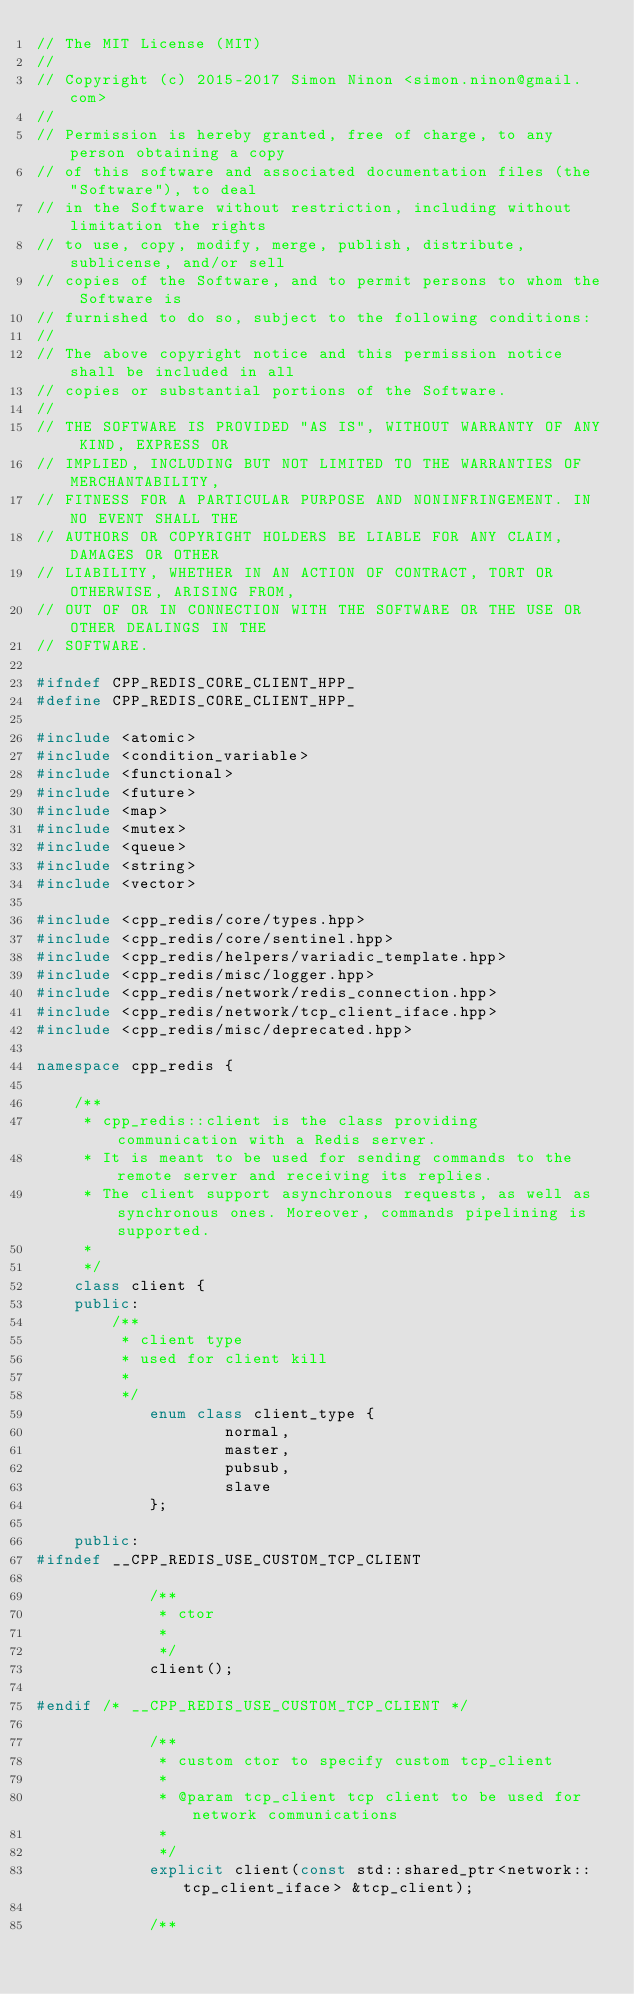Convert code to text. <code><loc_0><loc_0><loc_500><loc_500><_C++_>// The MIT License (MIT)
//
// Copyright (c) 2015-2017 Simon Ninon <simon.ninon@gmail.com>
//
// Permission is hereby granted, free of charge, to any person obtaining a copy
// of this software and associated documentation files (the "Software"), to deal
// in the Software without restriction, including without limitation the rights
// to use, copy, modify, merge, publish, distribute, sublicense, and/or sell
// copies of the Software, and to permit persons to whom the Software is
// furnished to do so, subject to the following conditions:
//
// The above copyright notice and this permission notice shall be included in all
// copies or substantial portions of the Software.
//
// THE SOFTWARE IS PROVIDED "AS IS", WITHOUT WARRANTY OF ANY KIND, EXPRESS OR
// IMPLIED, INCLUDING BUT NOT LIMITED TO THE WARRANTIES OF MERCHANTABILITY,
// FITNESS FOR A PARTICULAR PURPOSE AND NONINFRINGEMENT. IN NO EVENT SHALL THE
// AUTHORS OR COPYRIGHT HOLDERS BE LIABLE FOR ANY CLAIM, DAMAGES OR OTHER
// LIABILITY, WHETHER IN AN ACTION OF CONTRACT, TORT OR OTHERWISE, ARISING FROM,
// OUT OF OR IN CONNECTION WITH THE SOFTWARE OR THE USE OR OTHER DEALINGS IN THE
// SOFTWARE.

#ifndef CPP_REDIS_CORE_CLIENT_HPP_
#define CPP_REDIS_CORE_CLIENT_HPP_

#include <atomic>
#include <condition_variable>
#include <functional>
#include <future>
#include <map>
#include <mutex>
#include <queue>
#include <string>
#include <vector>

#include <cpp_redis/core/types.hpp>
#include <cpp_redis/core/sentinel.hpp>
#include <cpp_redis/helpers/variadic_template.hpp>
#include <cpp_redis/misc/logger.hpp>
#include <cpp_redis/network/redis_connection.hpp>
#include <cpp_redis/network/tcp_client_iface.hpp>
#include <cpp_redis/misc/deprecated.hpp>

namespace cpp_redis {

	/**
	 * cpp_redis::client is the class providing communication with a Redis server.
	 * It is meant to be used for sending commands to the remote server and receiving its replies.
	 * The client support asynchronous requests, as well as synchronous ones. Moreover, commands pipelining is supported.
	 *
	 */
	class client {
	public:
		/**
		 * client type
		 * used for client kill
		 *
		 */
			enum class client_type {
					normal,
					master,
					pubsub,
					slave
			};

	public:
#ifndef __CPP_REDIS_USE_CUSTOM_TCP_CLIENT

			/**
			 * ctor
			 *
			 */
			client();

#endif /* __CPP_REDIS_USE_CUSTOM_TCP_CLIENT */

			/**
			 * custom ctor to specify custom tcp_client
			 *
			 * @param tcp_client tcp client to be used for network communications
			 *
			 */
			explicit client(const std::shared_ptr<network::tcp_client_iface> &tcp_client);

			/**</code> 